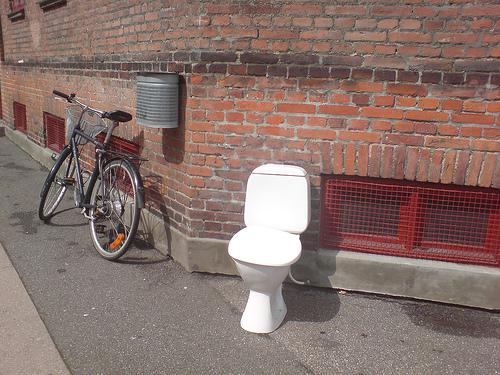Question: what color is the toilet?
Choices:
A. Yellow.
B. Gray.
C. White.
D. Red.
Answer with the letter. Answer: C Question: what are the dark images reflecting on the ground?
Choices:
A. Projections.
B. Pictures.
C. Figures.
D. Shadows.
Answer with the letter. Answer: D Question: who is sitting on the toilet?
Choices:
A. One person.
B. Two people.
C. Three people.
D. Noone.
Answer with the letter. Answer: D Question: what material is the building made of?
Choices:
A. Wood.
B. Stone.
C. Bricks.
D. Metal.
Answer with the letter. Answer: C 